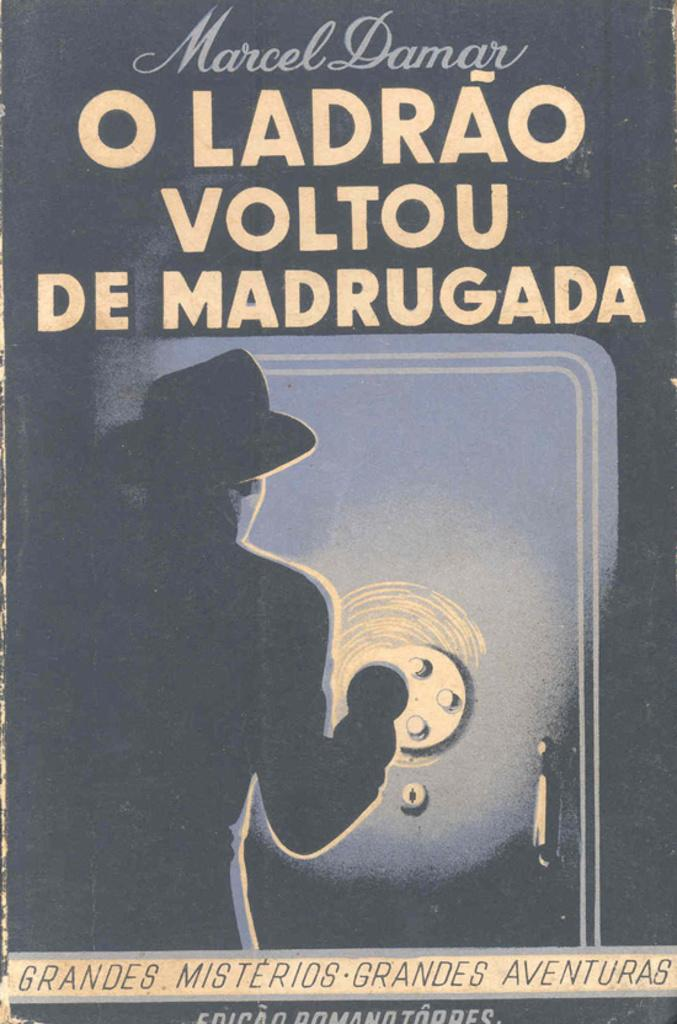<image>
Offer a succinct explanation of the picture presented. a book by Marcel Damer has a man breaking into a safe 